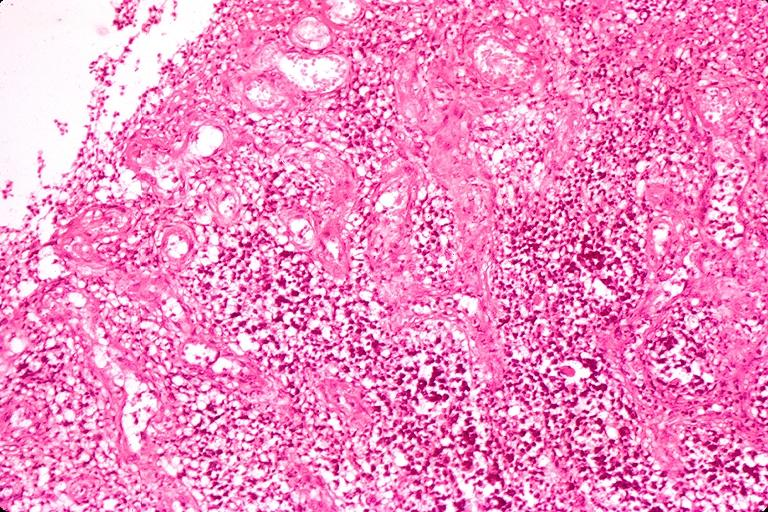s oral present?
Answer the question using a single word or phrase. Yes 